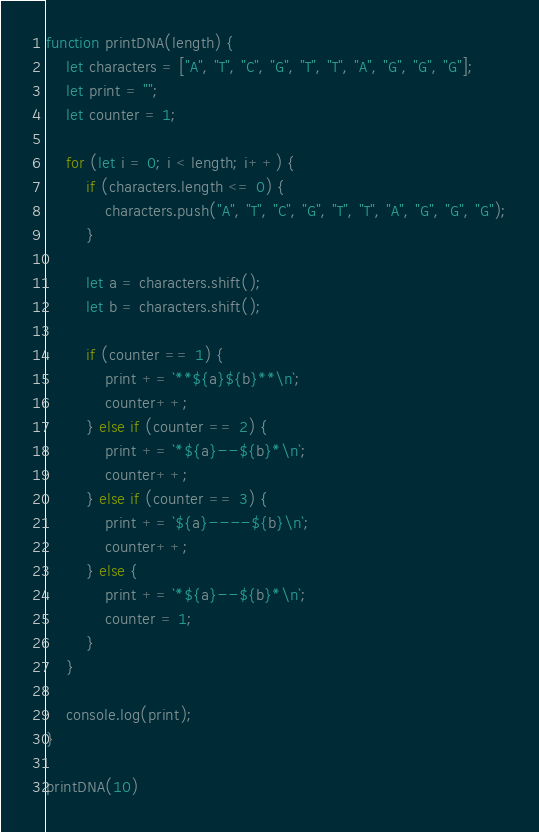Convert code to text. <code><loc_0><loc_0><loc_500><loc_500><_JavaScript_>function printDNA(length) {
    let characters = ["A", "T", "C", "G", "T", "T", "A", "G", "G", "G"];
    let print = "";
    let counter = 1;

    for (let i = 0; i < length; i++) {
        if (characters.length <= 0) {
            characters.push("A", "T", "C", "G", "T", "T", "A", "G", "G", "G");
        }

        let a = characters.shift();
        let b = characters.shift();

        if (counter == 1) {
            print += `**${a}${b}**\n`;
            counter++;
        } else if (counter == 2) {
            print += `*${a}--${b}*\n`;
            counter++;
        } else if (counter == 3) {
            print += `${a}----${b}\n`;
            counter++;
        } else {
            print += `*${a}--${b}*\n`;
            counter = 1;
        }
    }

    console.log(print);
}

printDNA(10)</code> 